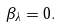Convert formula to latex. <formula><loc_0><loc_0><loc_500><loc_500>\beta _ { \lambda } = 0 .</formula> 